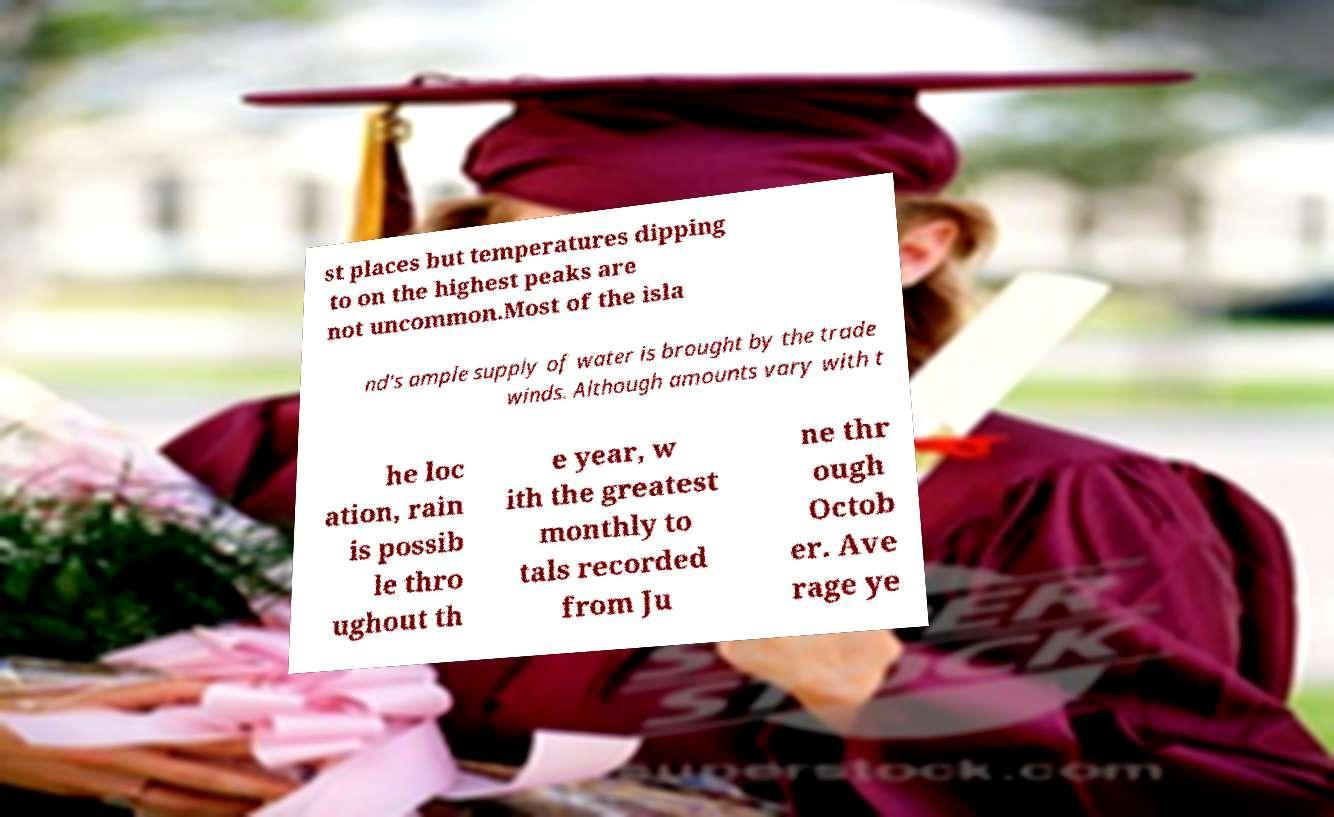Could you assist in decoding the text presented in this image and type it out clearly? st places but temperatures dipping to on the highest peaks are not uncommon.Most of the isla nd's ample supply of water is brought by the trade winds. Although amounts vary with t he loc ation, rain is possib le thro ughout th e year, w ith the greatest monthly to tals recorded from Ju ne thr ough Octob er. Ave rage ye 